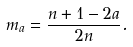<formula> <loc_0><loc_0><loc_500><loc_500>m _ { a } = \frac { n + 1 - 2 a } { 2 n } .</formula> 